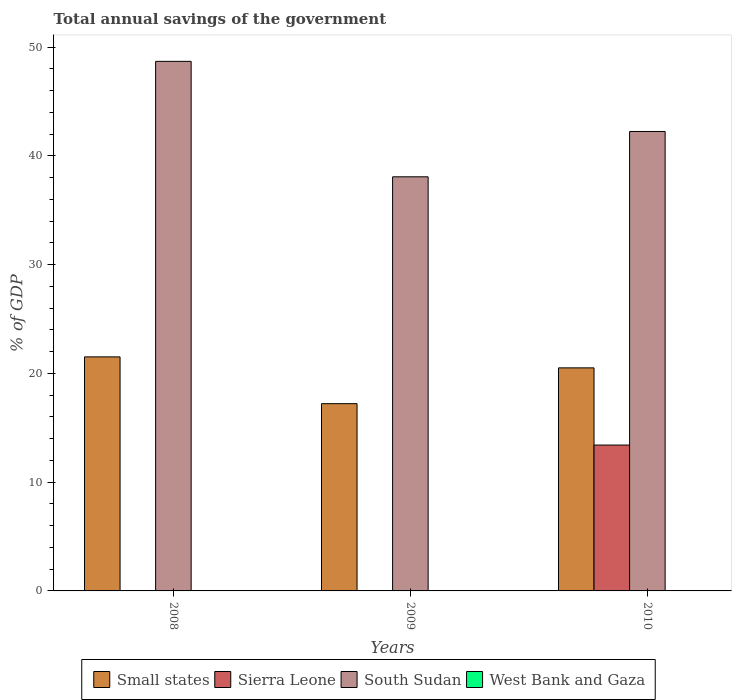Are the number of bars per tick equal to the number of legend labels?
Provide a short and direct response. No. How many bars are there on the 2nd tick from the right?
Keep it short and to the point. 2. What is the label of the 1st group of bars from the left?
Keep it short and to the point. 2008. In how many cases, is the number of bars for a given year not equal to the number of legend labels?
Your response must be concise. 3. What is the total annual savings of the government in South Sudan in 2010?
Keep it short and to the point. 42.24. Across all years, what is the maximum total annual savings of the government in Small states?
Offer a very short reply. 21.52. What is the total total annual savings of the government in South Sudan in the graph?
Offer a very short reply. 129.01. What is the difference between the total annual savings of the government in Small states in 2008 and that in 2010?
Your response must be concise. 1.01. What is the difference between the total annual savings of the government in West Bank and Gaza in 2010 and the total annual savings of the government in South Sudan in 2009?
Your answer should be very brief. -38.08. What is the average total annual savings of the government in Sierra Leone per year?
Your answer should be very brief. 4.47. In the year 2010, what is the difference between the total annual savings of the government in South Sudan and total annual savings of the government in Sierra Leone?
Give a very brief answer. 28.83. What is the ratio of the total annual savings of the government in South Sudan in 2008 to that in 2010?
Give a very brief answer. 1.15. Is the total annual savings of the government in Small states in 2008 less than that in 2009?
Offer a very short reply. No. What is the difference between the highest and the second highest total annual savings of the government in Small states?
Your answer should be very brief. 1.01. What is the difference between the highest and the lowest total annual savings of the government in Sierra Leone?
Make the answer very short. 13.41. In how many years, is the total annual savings of the government in South Sudan greater than the average total annual savings of the government in South Sudan taken over all years?
Offer a very short reply. 1. Is it the case that in every year, the sum of the total annual savings of the government in Small states and total annual savings of the government in South Sudan is greater than the sum of total annual savings of the government in Sierra Leone and total annual savings of the government in West Bank and Gaza?
Make the answer very short. Yes. How many bars are there?
Your answer should be compact. 7. How many years are there in the graph?
Provide a short and direct response. 3. Does the graph contain any zero values?
Keep it short and to the point. Yes. Does the graph contain grids?
Offer a terse response. No. How are the legend labels stacked?
Provide a succinct answer. Horizontal. What is the title of the graph?
Your response must be concise. Total annual savings of the government. What is the label or title of the X-axis?
Keep it short and to the point. Years. What is the label or title of the Y-axis?
Provide a succinct answer. % of GDP. What is the % of GDP of Small states in 2008?
Your answer should be compact. 21.52. What is the % of GDP in South Sudan in 2008?
Your answer should be very brief. 48.69. What is the % of GDP of Small states in 2009?
Offer a terse response. 17.22. What is the % of GDP in Sierra Leone in 2009?
Provide a succinct answer. 0. What is the % of GDP of South Sudan in 2009?
Provide a succinct answer. 38.08. What is the % of GDP in West Bank and Gaza in 2009?
Provide a succinct answer. 0. What is the % of GDP in Small states in 2010?
Provide a short and direct response. 20.51. What is the % of GDP in Sierra Leone in 2010?
Give a very brief answer. 13.41. What is the % of GDP in South Sudan in 2010?
Provide a succinct answer. 42.24. Across all years, what is the maximum % of GDP in Small states?
Your response must be concise. 21.52. Across all years, what is the maximum % of GDP of Sierra Leone?
Keep it short and to the point. 13.41. Across all years, what is the maximum % of GDP of South Sudan?
Make the answer very short. 48.69. Across all years, what is the minimum % of GDP in Small states?
Provide a short and direct response. 17.22. Across all years, what is the minimum % of GDP of Sierra Leone?
Offer a terse response. 0. Across all years, what is the minimum % of GDP in South Sudan?
Provide a succinct answer. 38.08. What is the total % of GDP of Small states in the graph?
Provide a short and direct response. 59.24. What is the total % of GDP of Sierra Leone in the graph?
Offer a very short reply. 13.41. What is the total % of GDP of South Sudan in the graph?
Your answer should be very brief. 129.01. What is the total % of GDP of West Bank and Gaza in the graph?
Give a very brief answer. 0. What is the difference between the % of GDP of Small states in 2008 and that in 2009?
Provide a succinct answer. 4.3. What is the difference between the % of GDP in South Sudan in 2008 and that in 2009?
Provide a short and direct response. 10.61. What is the difference between the % of GDP in Small states in 2008 and that in 2010?
Offer a very short reply. 1.01. What is the difference between the % of GDP in South Sudan in 2008 and that in 2010?
Keep it short and to the point. 6.45. What is the difference between the % of GDP of Small states in 2009 and that in 2010?
Offer a very short reply. -3.29. What is the difference between the % of GDP in South Sudan in 2009 and that in 2010?
Your answer should be very brief. -4.17. What is the difference between the % of GDP in Small states in 2008 and the % of GDP in South Sudan in 2009?
Offer a terse response. -16.56. What is the difference between the % of GDP in Small states in 2008 and the % of GDP in Sierra Leone in 2010?
Offer a very short reply. 8.11. What is the difference between the % of GDP of Small states in 2008 and the % of GDP of South Sudan in 2010?
Ensure brevity in your answer.  -20.72. What is the difference between the % of GDP in Small states in 2009 and the % of GDP in Sierra Leone in 2010?
Give a very brief answer. 3.81. What is the difference between the % of GDP in Small states in 2009 and the % of GDP in South Sudan in 2010?
Offer a terse response. -25.03. What is the average % of GDP in Small states per year?
Your answer should be compact. 19.75. What is the average % of GDP in Sierra Leone per year?
Give a very brief answer. 4.47. What is the average % of GDP of South Sudan per year?
Your response must be concise. 43. What is the average % of GDP in West Bank and Gaza per year?
Provide a succinct answer. 0. In the year 2008, what is the difference between the % of GDP in Small states and % of GDP in South Sudan?
Give a very brief answer. -27.17. In the year 2009, what is the difference between the % of GDP of Small states and % of GDP of South Sudan?
Offer a terse response. -20.86. In the year 2010, what is the difference between the % of GDP of Small states and % of GDP of Sierra Leone?
Keep it short and to the point. 7.1. In the year 2010, what is the difference between the % of GDP of Small states and % of GDP of South Sudan?
Provide a short and direct response. -21.73. In the year 2010, what is the difference between the % of GDP of Sierra Leone and % of GDP of South Sudan?
Your answer should be very brief. -28.83. What is the ratio of the % of GDP of Small states in 2008 to that in 2009?
Provide a succinct answer. 1.25. What is the ratio of the % of GDP in South Sudan in 2008 to that in 2009?
Make the answer very short. 1.28. What is the ratio of the % of GDP of Small states in 2008 to that in 2010?
Make the answer very short. 1.05. What is the ratio of the % of GDP of South Sudan in 2008 to that in 2010?
Give a very brief answer. 1.15. What is the ratio of the % of GDP in Small states in 2009 to that in 2010?
Keep it short and to the point. 0.84. What is the ratio of the % of GDP of South Sudan in 2009 to that in 2010?
Provide a short and direct response. 0.9. What is the difference between the highest and the second highest % of GDP in South Sudan?
Offer a very short reply. 6.45. What is the difference between the highest and the lowest % of GDP in Small states?
Your answer should be compact. 4.3. What is the difference between the highest and the lowest % of GDP in Sierra Leone?
Offer a very short reply. 13.41. What is the difference between the highest and the lowest % of GDP of South Sudan?
Your answer should be very brief. 10.61. 